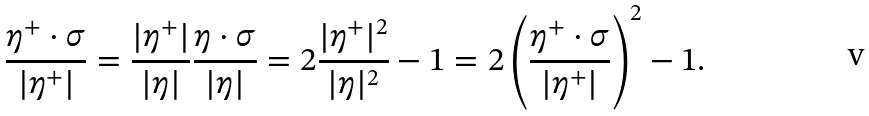Convert formula to latex. <formula><loc_0><loc_0><loc_500><loc_500>\frac { \eta ^ { + } \cdot \sigma } { | \eta ^ { + } | } = \frac { | \eta ^ { + } | } { | \eta | } \frac { \eta \cdot \sigma } { | \eta | } = 2 \frac { | \eta ^ { + } | ^ { 2 } } { | \eta | ^ { 2 } } - 1 = 2 \left ( \frac { \eta ^ { + } \cdot \sigma } { | \eta ^ { + } | } \right ) ^ { 2 } - 1 .</formula> 